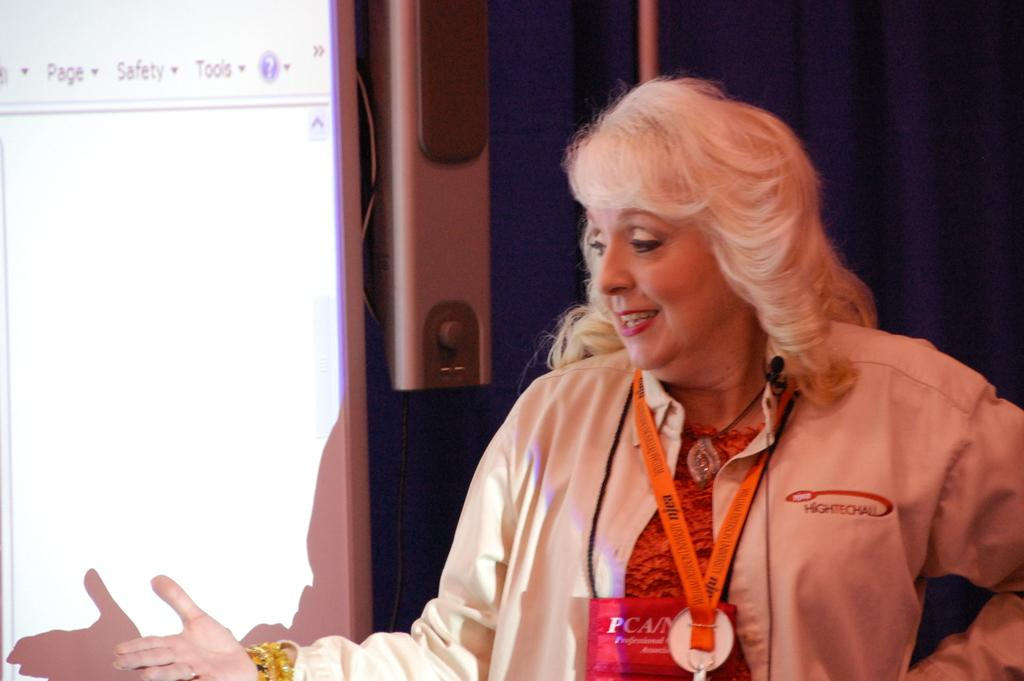What is the person in the image wearing? The person is wearing a dress in the image. Can you describe any additional items the person is wearing? The person is also wearing an identification card. What color cloth can be seen in the background of the image? There is a blue color cloth in the background of the image. What objects are present in the background of the image? There are speakers and a screen in the background of the image. How does the person in the image help beginners learn to burst? There is no mention of helping beginners or bursting in the image; the image only shows a person wearing a dress and an identification card, with a blue cloth and speakers in the background. 